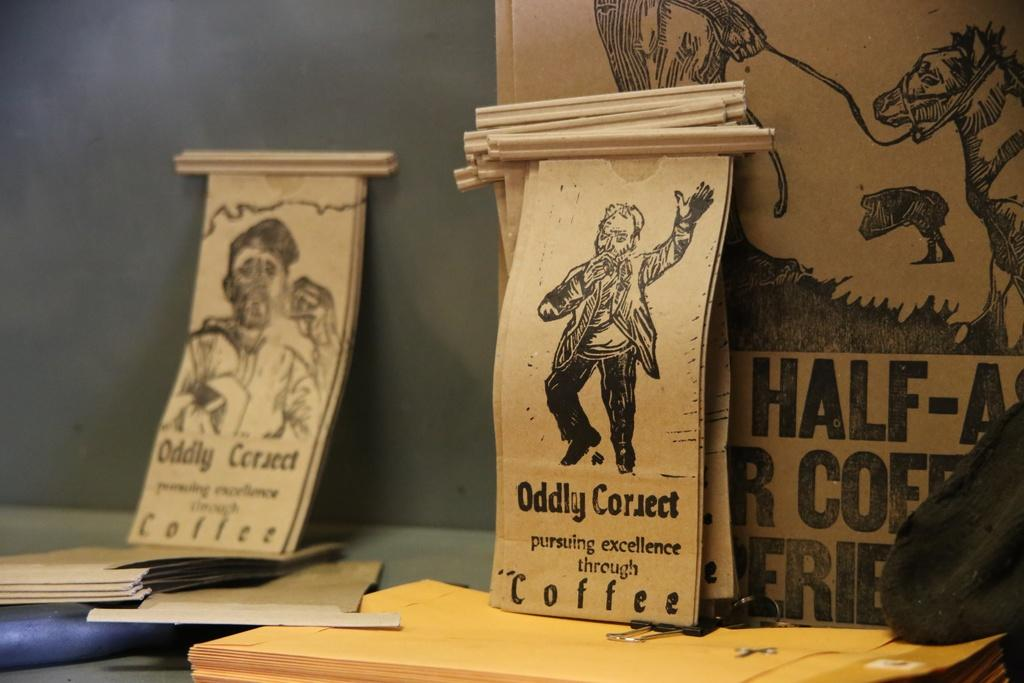<image>
Offer a succinct explanation of the picture presented. Scrolls that say "Oddly Correct Coffee" with drawings of people on them. 